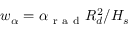<formula> <loc_0><loc_0><loc_500><loc_500>w _ { \alpha } = \alpha _ { r a d } R _ { d } ^ { 2 } / H _ { s }</formula> 